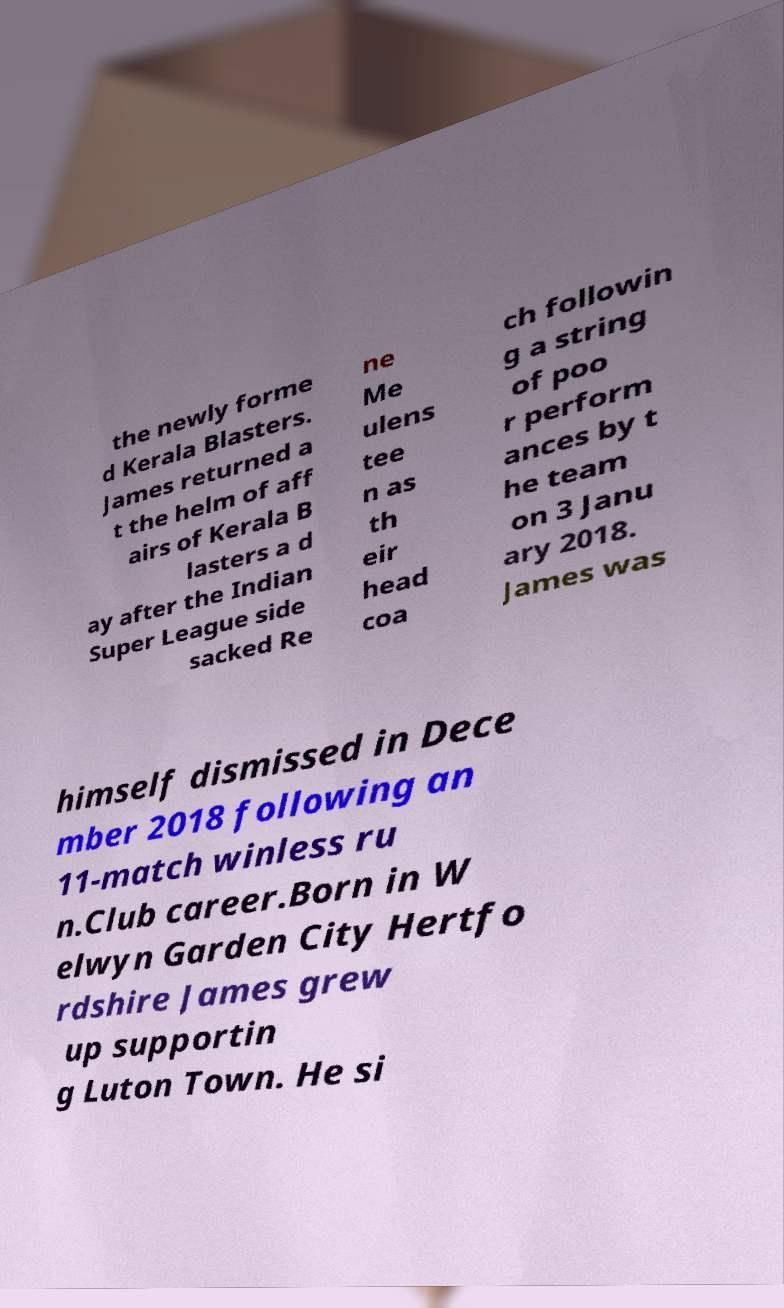For documentation purposes, I need the text within this image transcribed. Could you provide that? the newly forme d Kerala Blasters. James returned a t the helm of aff airs of Kerala B lasters a d ay after the Indian Super League side sacked Re ne Me ulens tee n as th eir head coa ch followin g a string of poo r perform ances by t he team on 3 Janu ary 2018. James was himself dismissed in Dece mber 2018 following an 11-match winless ru n.Club career.Born in W elwyn Garden City Hertfo rdshire James grew up supportin g Luton Town. He si 